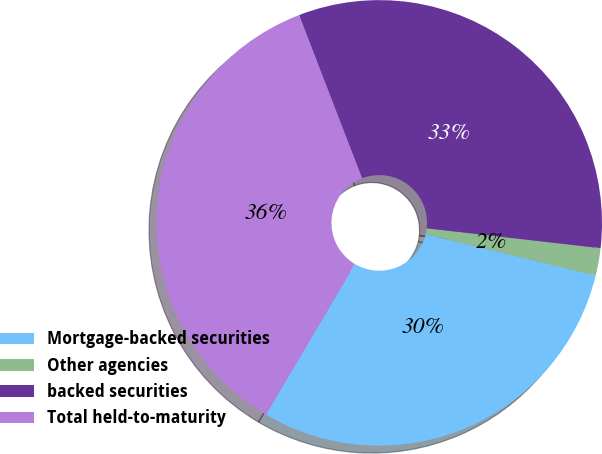Convert chart to OTSL. <chart><loc_0><loc_0><loc_500><loc_500><pie_chart><fcel>Mortgage-backed securities<fcel>Other agencies<fcel>backed securities<fcel>Total held-to-maturity<nl><fcel>29.7%<fcel>1.98%<fcel>32.67%<fcel>35.65%<nl></chart> 